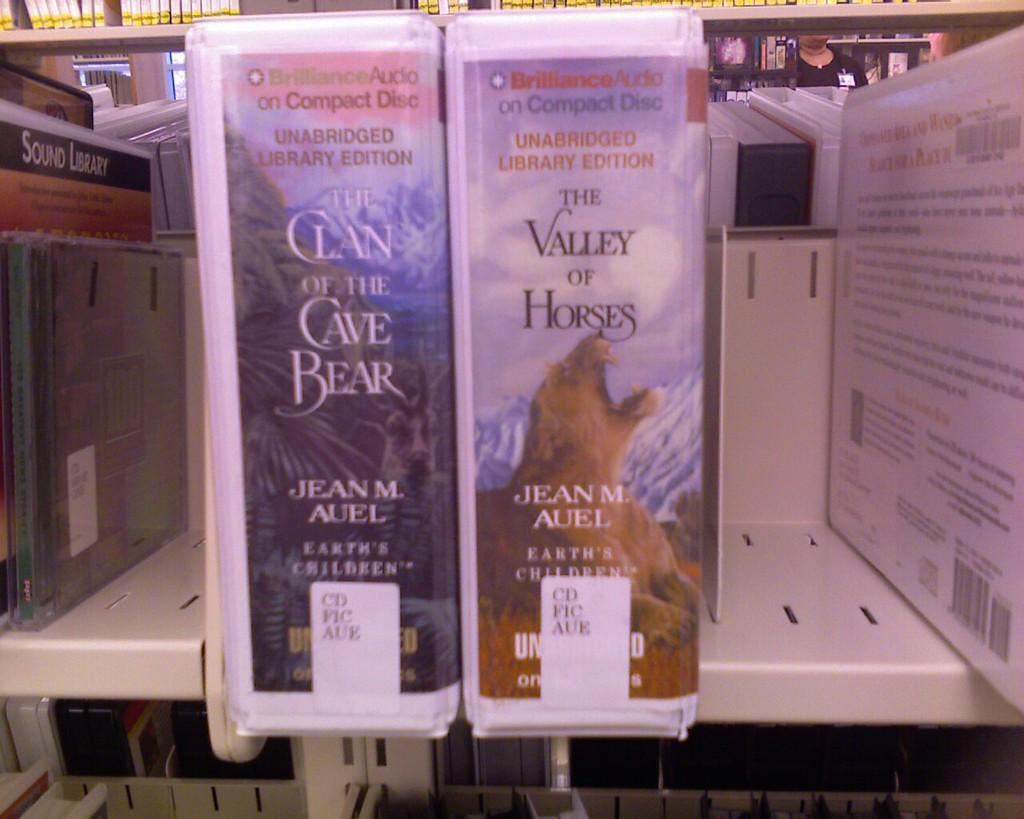<image>
Create a compact narrative representing the image presented. Two compact disc recordings of novels by Jean M. Auel sit side by side on a shelf. 